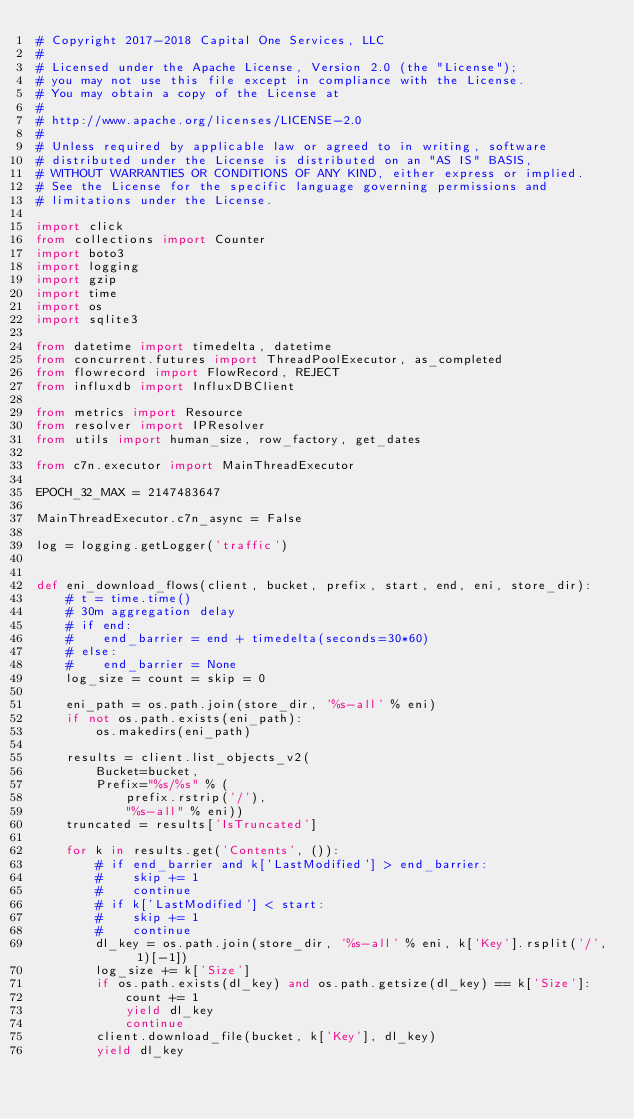Convert code to text. <code><loc_0><loc_0><loc_500><loc_500><_Python_># Copyright 2017-2018 Capital One Services, LLC
#
# Licensed under the Apache License, Version 2.0 (the "License");
# you may not use this file except in compliance with the License.
# You may obtain a copy of the License at
#
# http://www.apache.org/licenses/LICENSE-2.0
#
# Unless required by applicable law or agreed to in writing, software
# distributed under the License is distributed on an "AS IS" BASIS,
# WITHOUT WARRANTIES OR CONDITIONS OF ANY KIND, either express or implied.
# See the License for the specific language governing permissions and
# limitations under the License.

import click
from collections import Counter
import boto3
import logging
import gzip
import time
import os
import sqlite3

from datetime import timedelta, datetime
from concurrent.futures import ThreadPoolExecutor, as_completed
from flowrecord import FlowRecord, REJECT
from influxdb import InfluxDBClient

from metrics import Resource
from resolver import IPResolver
from utils import human_size, row_factory, get_dates

from c7n.executor import MainThreadExecutor

EPOCH_32_MAX = 2147483647

MainThreadExecutor.c7n_async = False

log = logging.getLogger('traffic')


def eni_download_flows(client, bucket, prefix, start, end, eni, store_dir):
    # t = time.time()
    # 30m aggregation delay
    # if end:
    #    end_barrier = end + timedelta(seconds=30*60)
    # else:
    #    end_barrier = None
    log_size = count = skip = 0

    eni_path = os.path.join(store_dir, '%s-all' % eni)
    if not os.path.exists(eni_path):
        os.makedirs(eni_path)

    results = client.list_objects_v2(
        Bucket=bucket,
        Prefix="%s/%s" % (
            prefix.rstrip('/'),
            "%s-all" % eni))
    truncated = results['IsTruncated']

    for k in results.get('Contents', ()):
        # if end_barrier and k['LastModified'] > end_barrier:
        #    skip += 1
        #    continue
        # if k['LastModified'] < start:
        #    skip += 1
        #    continue
        dl_key = os.path.join(store_dir, '%s-all' % eni, k['Key'].rsplit('/', 1)[-1])
        log_size += k['Size']
        if os.path.exists(dl_key) and os.path.getsize(dl_key) == k['Size']:
            count += 1
            yield dl_key
            continue
        client.download_file(bucket, k['Key'], dl_key)
        yield dl_key</code> 